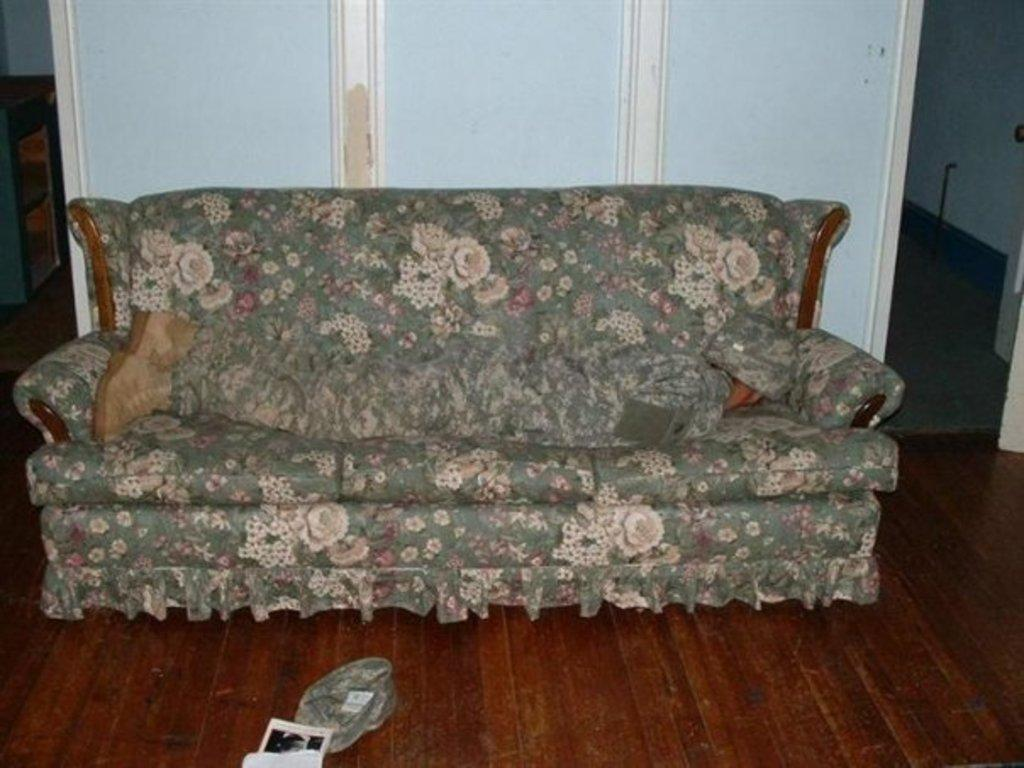What color is the floor in the image? The floor in the image is brown. What color is the sofa in the image? The sofa in the image is green. What color are the doors in the background of the image? The doors in the background of the image are white. How many tomatoes are on the green sofa in the image? There are no tomatoes present in the image; the green sofa is the only item mentioned in the facts. 